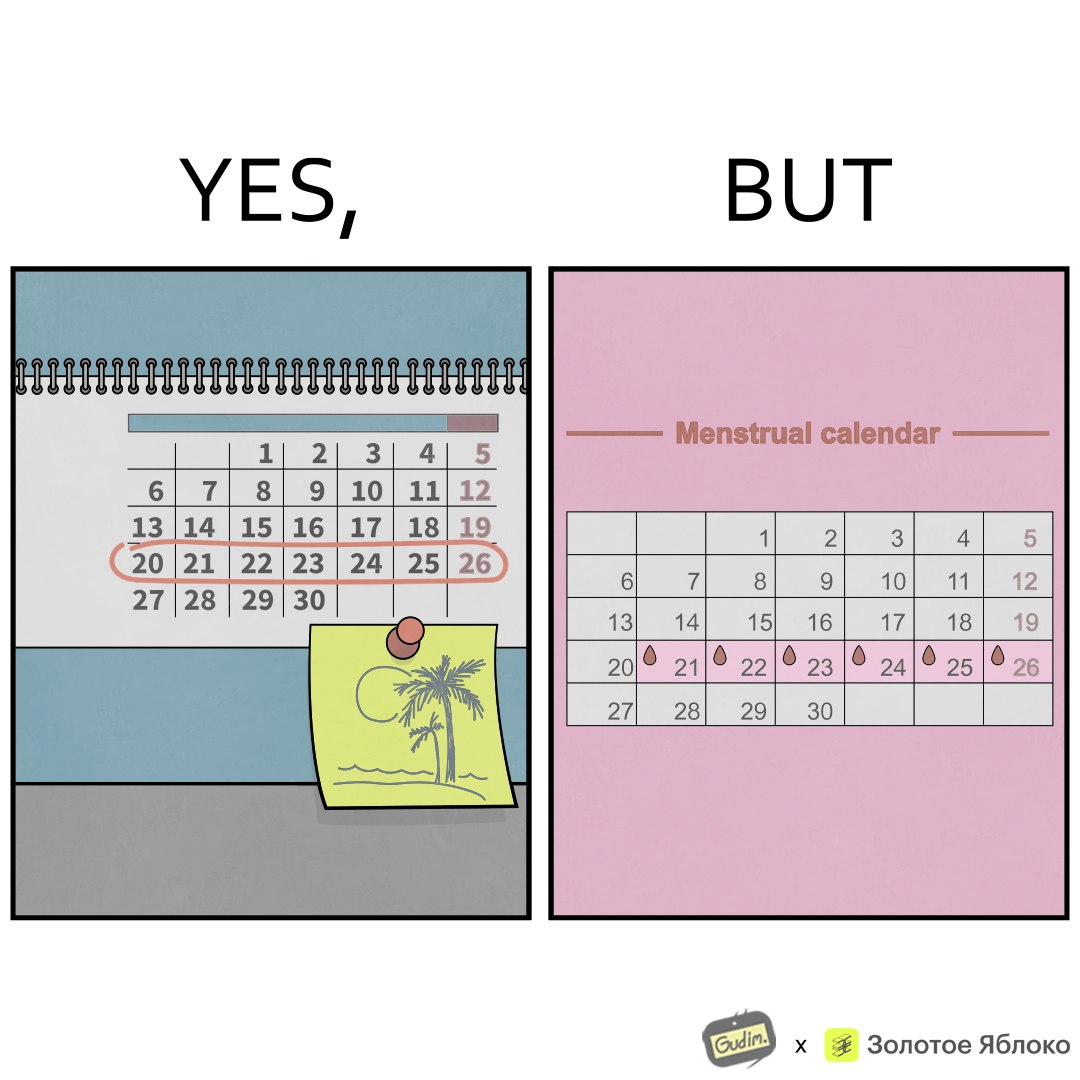Explain the humor or irony in this image. The images are funny since they show how women plan out holidays with much care but their menstrual cycles ruin their plans by causing trouble due to bleeding and discomfort that occur during menstruation 